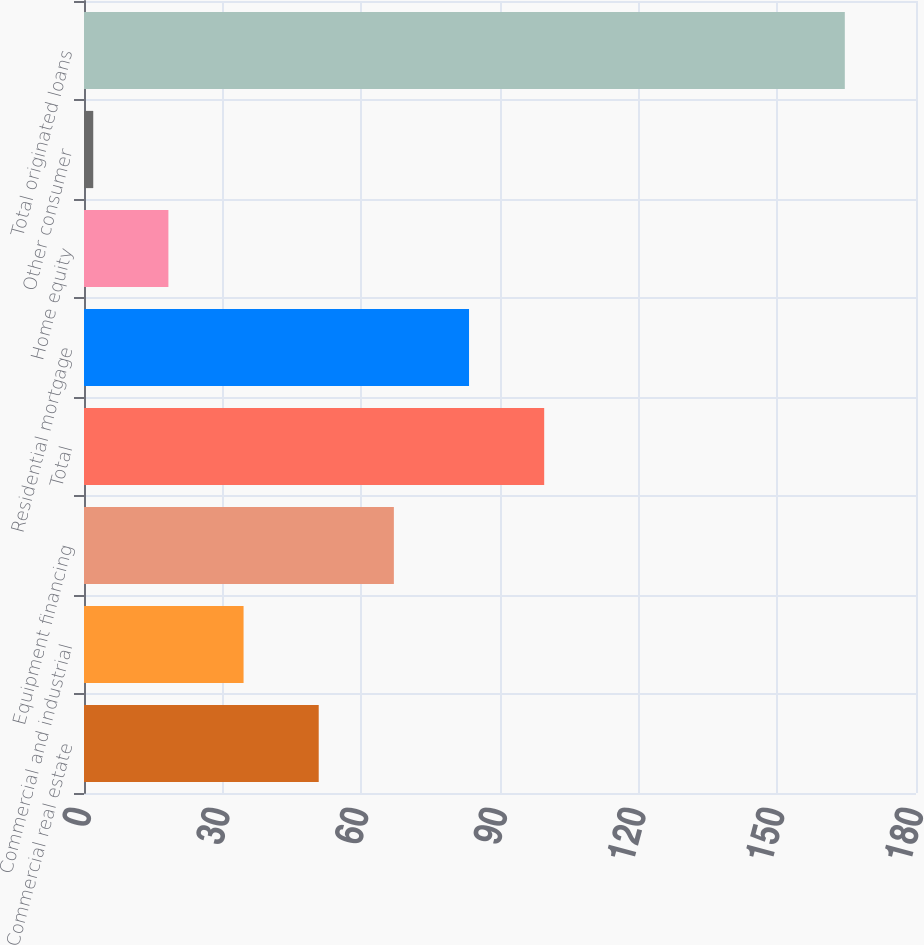Convert chart to OTSL. <chart><loc_0><loc_0><loc_500><loc_500><bar_chart><fcel>Commercial real estate<fcel>Commercial and industrial<fcel>Equipment financing<fcel>Total<fcel>Residential mortgage<fcel>Home equity<fcel>Other consumer<fcel>Total originated loans<nl><fcel>50.78<fcel>34.52<fcel>67.04<fcel>99.56<fcel>83.3<fcel>18.26<fcel>2<fcel>164.6<nl></chart> 